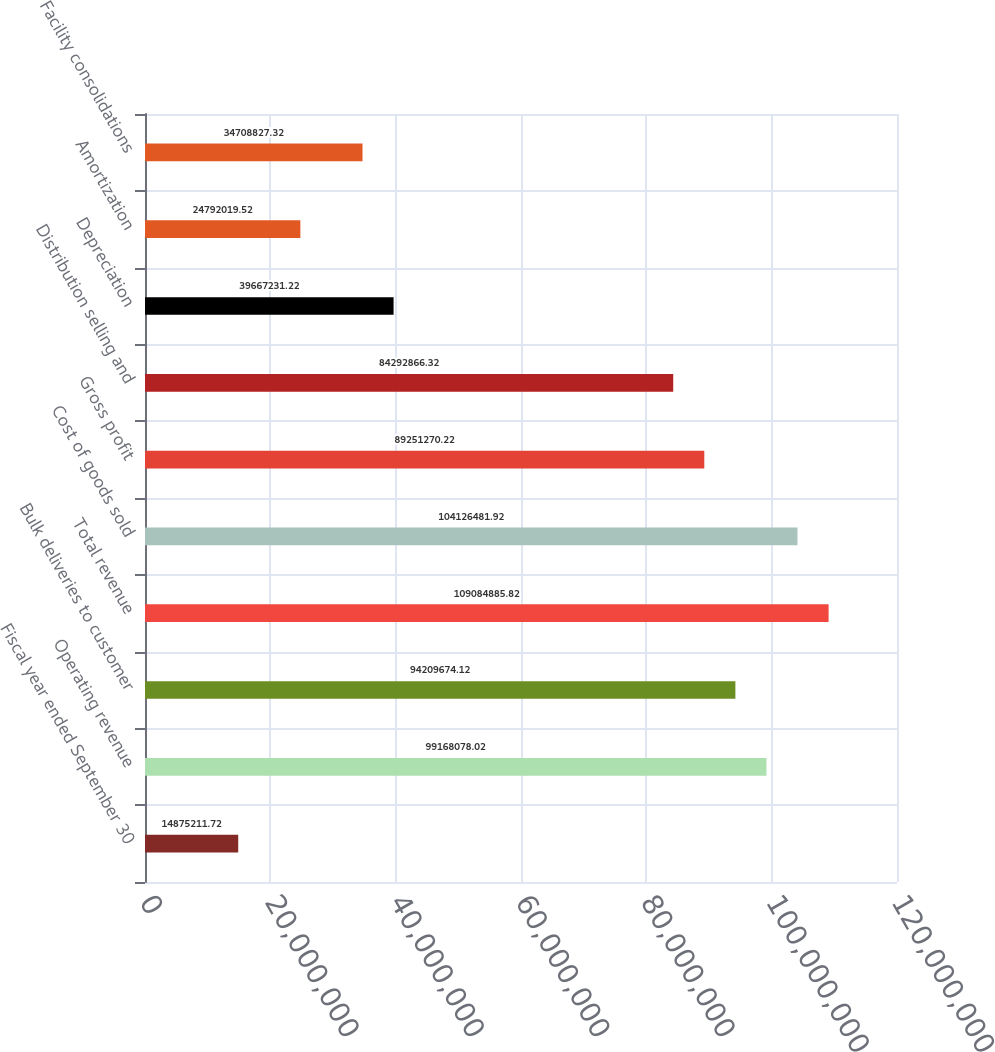Convert chart. <chart><loc_0><loc_0><loc_500><loc_500><bar_chart><fcel>Fiscal year ended September 30<fcel>Operating revenue<fcel>Bulk deliveries to customer<fcel>Total revenue<fcel>Cost of goods sold<fcel>Gross profit<fcel>Distribution selling and<fcel>Depreciation<fcel>Amortization<fcel>Facility consolidations<nl><fcel>1.48752e+07<fcel>9.91681e+07<fcel>9.42097e+07<fcel>1.09085e+08<fcel>1.04126e+08<fcel>8.92513e+07<fcel>8.42929e+07<fcel>3.96672e+07<fcel>2.4792e+07<fcel>3.47088e+07<nl></chart> 